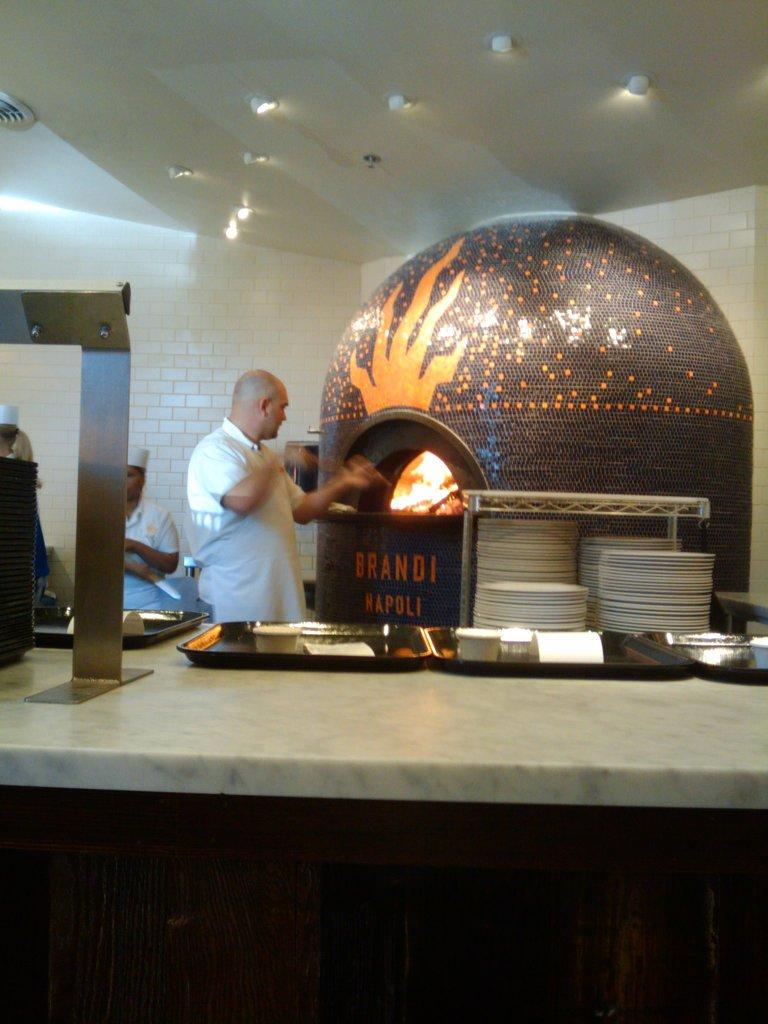Provide a one-sentence caption for the provided image. Under a brick oven, the words Brandi Napoli appear. 